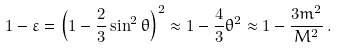Convert formula to latex. <formula><loc_0><loc_0><loc_500><loc_500>1 - \varepsilon = \left ( 1 - \frac { 2 } { 3 } \sin ^ { 2 } \theta \right ) ^ { 2 } \approx 1 - \frac { 4 } { 3 } \theta ^ { 2 } \approx 1 - \frac { 3 m ^ { 2 } } { M ^ { 2 } } \, .</formula> 